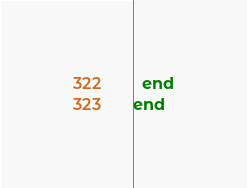Convert code to text. <code><loc_0><loc_0><loc_500><loc_500><_Ruby_>  end
end
</code> 